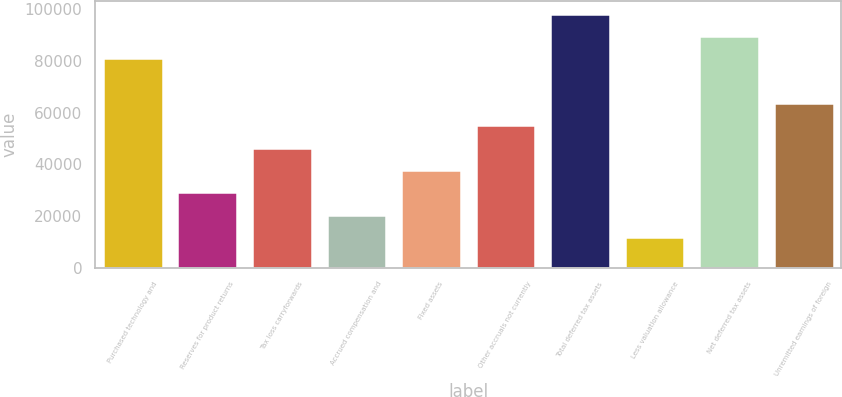Convert chart to OTSL. <chart><loc_0><loc_0><loc_500><loc_500><bar_chart><fcel>Purchased technology and<fcel>Reserves for product returns<fcel>Tax loss carryforwards<fcel>Accrued compensation and<fcel>Fixed assets<fcel>Other accruals not currently<fcel>Total deferred tax assets<fcel>Less valuation allowance<fcel>Net deferred tax assets<fcel>Unremitted earnings of foreign<nl><fcel>81003.5<fcel>29088.5<fcel>46393.5<fcel>20436<fcel>37741<fcel>55046<fcel>98308.5<fcel>11783.5<fcel>89656<fcel>63698.5<nl></chart> 